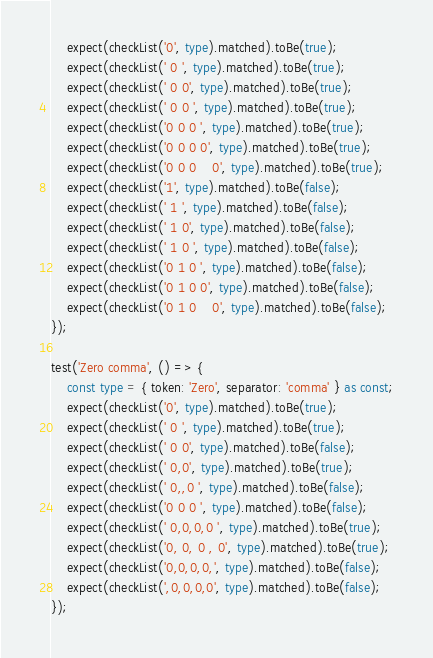<code> <loc_0><loc_0><loc_500><loc_500><_TypeScript_>	expect(checkList('0', type).matched).toBe(true);
	expect(checkList(' 0 ', type).matched).toBe(true);
	expect(checkList(' 0 0', type).matched).toBe(true);
	expect(checkList(' 0 0 ', type).matched).toBe(true);
	expect(checkList('0 0 0 ', type).matched).toBe(true);
	expect(checkList('0 0 0 0', type).matched).toBe(true);
	expect(checkList('0 0 0    0', type).matched).toBe(true);
	expect(checkList('1', type).matched).toBe(false);
	expect(checkList(' 1 ', type).matched).toBe(false);
	expect(checkList(' 1 0', type).matched).toBe(false);
	expect(checkList(' 1 0 ', type).matched).toBe(false);
	expect(checkList('0 1 0 ', type).matched).toBe(false);
	expect(checkList('0 1 0 0', type).matched).toBe(false);
	expect(checkList('0 1 0    0', type).matched).toBe(false);
});

test('Zero comma', () => {
	const type = { token: 'Zero', separator: 'comma' } as const;
	expect(checkList('0', type).matched).toBe(true);
	expect(checkList(' 0 ', type).matched).toBe(true);
	expect(checkList(' 0 0', type).matched).toBe(false);
	expect(checkList(' 0,0', type).matched).toBe(true);
	expect(checkList(' 0,,0 ', type).matched).toBe(false);
	expect(checkList('0 0 0 ', type).matched).toBe(false);
	expect(checkList(' 0,0,0,0 ', type).matched).toBe(true);
	expect(checkList('0, 0, 0 , 0', type).matched).toBe(true);
	expect(checkList('0,0,0,0,', type).matched).toBe(false);
	expect(checkList(',0,0,0,0', type).matched).toBe(false);
});
</code> 